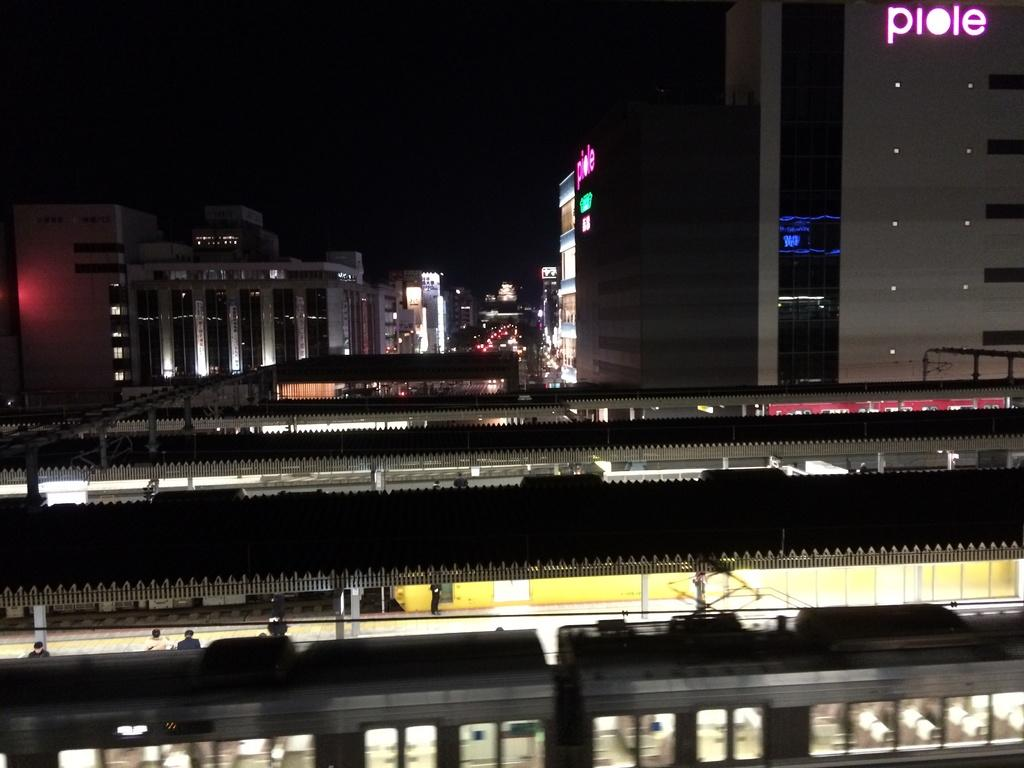<image>
Share a concise interpretation of the image provided. A picture of a building at night with the sign Piole on it 